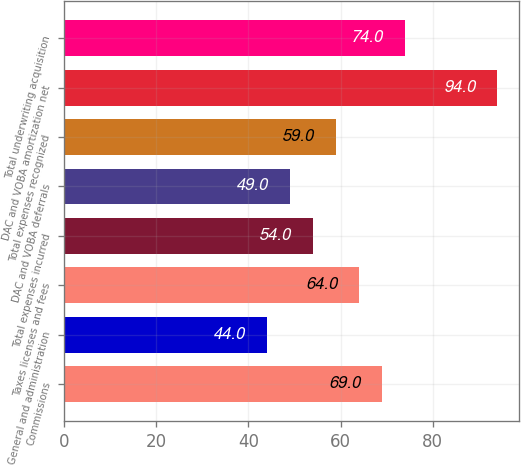Convert chart to OTSL. <chart><loc_0><loc_0><loc_500><loc_500><bar_chart><fcel>Commissions<fcel>General and administration<fcel>Taxes licenses and fees<fcel>Total expenses incurred<fcel>DAC and VOBA deferrals<fcel>Total expenses recognized<fcel>DAC and VOBA amortization net<fcel>Total underwriting acquisition<nl><fcel>69<fcel>44<fcel>64<fcel>54<fcel>49<fcel>59<fcel>94<fcel>74<nl></chart> 